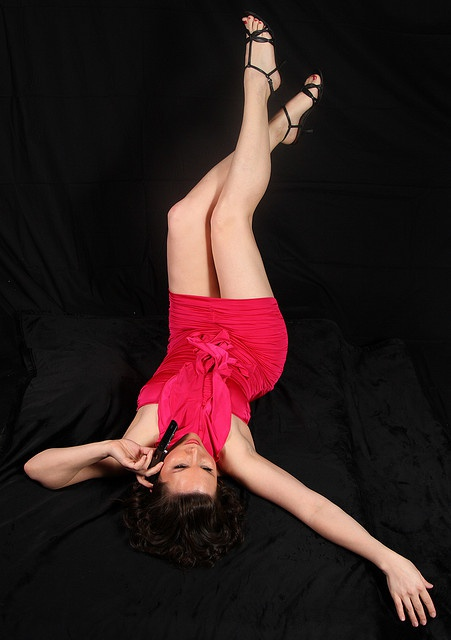Describe the objects in this image and their specific colors. I can see bed in black, tan, maroon, and brown tones, people in black, tan, and brown tones, and cell phone in black, maroon, gray, and teal tones in this image. 